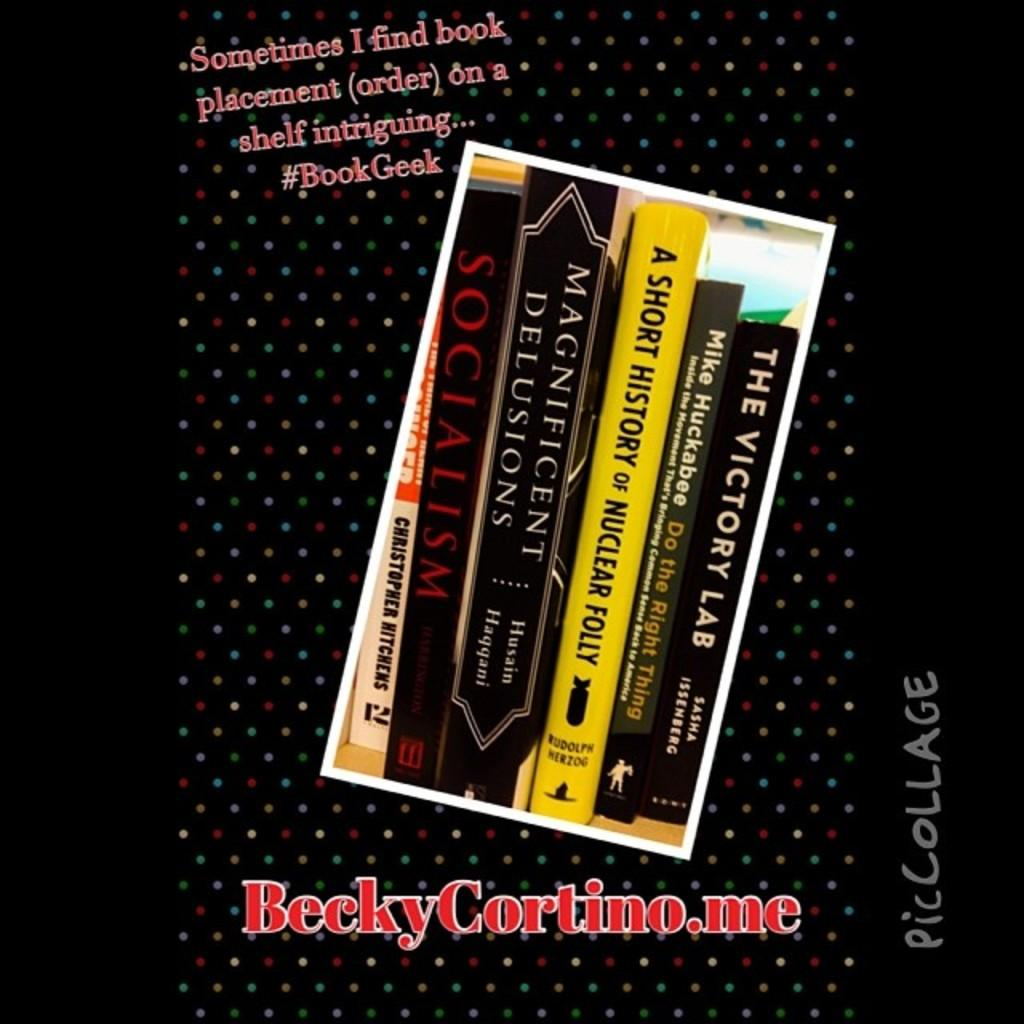<image>
Share a concise interpretation of the image provided. Books are shown in an advertisement including one titled A Short History of Nuclear Folly. 